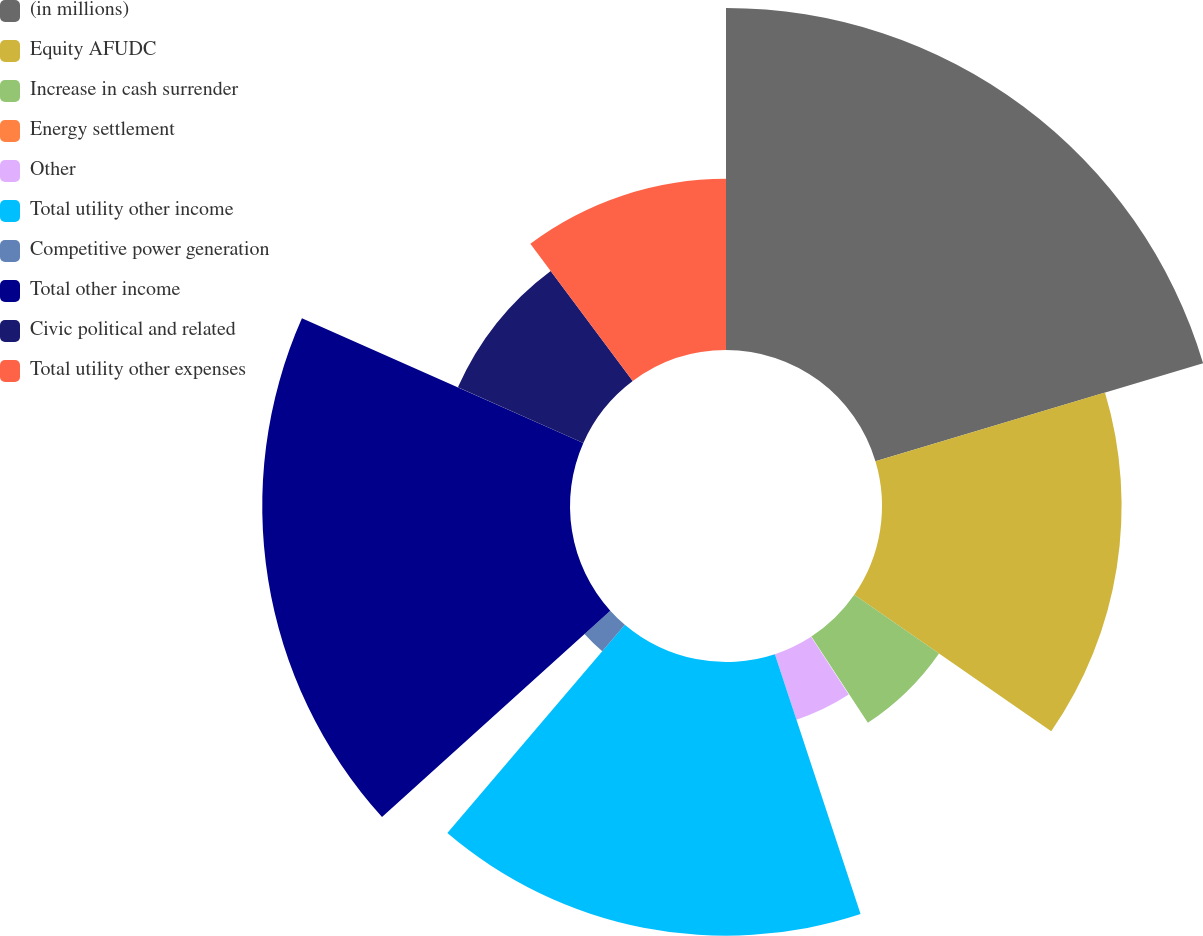Convert chart. <chart><loc_0><loc_0><loc_500><loc_500><pie_chart><fcel>(in millions)<fcel>Equity AFUDC<fcel>Increase in cash surrender<fcel>Energy settlement<fcel>Other<fcel>Total utility other income<fcel>Competitive power generation<fcel>Total other income<fcel>Civic political and related<fcel>Total utility other expenses<nl><fcel>20.37%<fcel>14.27%<fcel>6.14%<fcel>0.04%<fcel>4.11%<fcel>16.3%<fcel>2.07%<fcel>18.33%<fcel>8.17%<fcel>10.2%<nl></chart> 